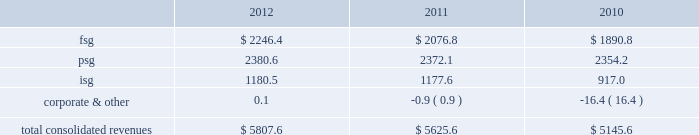Strategy our mission is to achieve sustainable revenue and earnings growth through providing superior solutions to our customers .
Our strategy to achieve this has been and will continue to be built on the following pillars : 2022 expand client relationships 2014 the overall market we serve continues to gravitate beyond single-product purchases to multi-solution partnerships .
As the market dynamics shift , we expect our clients to rely more on our multidimensional service offerings .
Our leveraged solutions and processing expertise can drive meaningful value and cost savings to our clients through more efficient operating processes , improved service quality and speed for our clients' customers .
2022 buy , build or partner to add solutions to cross-sell 2014 we continue to invest in growth through internal product development , as well as through product-focused or market-centric acquisitions that complement and extend our existing capabilities and provide us with additional solutions to cross-sell .
We also partner from time to time with other entities to provide comprehensive offerings to our customers .
By investing in solution innovation and integration , we continue to expand our value proposition to clients .
2022 support our clients through market transformation 2014 the changing market dynamics are transforming the way our clients operate , which is driving incremental demand for our leveraged solutions , consulting expertise , and services around intellectual property .
Our depth of services capabilities enables us to become involved earlier in the planning and design process to assist our clients as they manage through these changes .
2022 continually improve to drive margin expansion 2014 we strive to optimize our performance through investments in infrastructure enhancements and other measures that are designed to drive organic revenue growth and margin expansion .
2022 build global diversification 2014 we continue to deploy resources in emerging global markets where we expect to achieve meaningful scale .
Revenues by segment the table below summarizes the revenues by our reporting segments ( in millions ) : .
Financial solutions group the focus of fsg is to provide the most comprehensive software and services for the core processing , customer channel , treasury services , cash management , wealth management and capital market operations of our financial institution customers in north america .
We service the core and related ancillary processing needs of north american banks , credit unions , automotive financial companies , commercial lenders , and independent community and savings institutions .
Fis offers a broad selection of in-house and outsourced solutions to banking customers that span the range of asset sizes .
Fsg customers are typically committed under multi-year contracts that provide a stable , recurring revenue base and opportunities for cross-selling additional financial and payments offerings .
We employ several business models to provide our solutions to our customers .
We typically deliver the highest value to our customers when we combine our software applications and deliver them in one of several types of outsourcing arrangements , such as an application service provider , facilities management processing or an application management arrangement .
We are also able to deliver individual applications through a software licensing arrangement .
Based upon our expertise gained through the foregoing arrangements , some clients also retain us to manage their it operations without using any of our proprietary software .
Our solutions in this segment include: .
What percent of total consolidate revenue was the psg segment in 2012? 
Computations: (2380.6 / 5807.6)
Answer: 0.40991. Strategy our mission is to achieve sustainable revenue and earnings growth through providing superior solutions to our customers .
Our strategy to achieve this has been and will continue to be built on the following pillars : 2022 expand client relationships 2014 the overall market we serve continues to gravitate beyond single-product purchases to multi-solution partnerships .
As the market dynamics shift , we expect our clients to rely more on our multidimensional service offerings .
Our leveraged solutions and processing expertise can drive meaningful value and cost savings to our clients through more efficient operating processes , improved service quality and speed for our clients' customers .
2022 buy , build or partner to add solutions to cross-sell 2014 we continue to invest in growth through internal product development , as well as through product-focused or market-centric acquisitions that complement and extend our existing capabilities and provide us with additional solutions to cross-sell .
We also partner from time to time with other entities to provide comprehensive offerings to our customers .
By investing in solution innovation and integration , we continue to expand our value proposition to clients .
2022 support our clients through market transformation 2014 the changing market dynamics are transforming the way our clients operate , which is driving incremental demand for our leveraged solutions , consulting expertise , and services around intellectual property .
Our depth of services capabilities enables us to become involved earlier in the planning and design process to assist our clients as they manage through these changes .
2022 continually improve to drive margin expansion 2014 we strive to optimize our performance through investments in infrastructure enhancements and other measures that are designed to drive organic revenue growth and margin expansion .
2022 build global diversification 2014 we continue to deploy resources in emerging global markets where we expect to achieve meaningful scale .
Revenues by segment the table below summarizes the revenues by our reporting segments ( in millions ) : .
Financial solutions group the focus of fsg is to provide the most comprehensive software and services for the core processing , customer channel , treasury services , cash management , wealth management and capital market operations of our financial institution customers in north america .
We service the core and related ancillary processing needs of north american banks , credit unions , automotive financial companies , commercial lenders , and independent community and savings institutions .
Fis offers a broad selection of in-house and outsourced solutions to banking customers that span the range of asset sizes .
Fsg customers are typically committed under multi-year contracts that provide a stable , recurring revenue base and opportunities for cross-selling additional financial and payments offerings .
We employ several business models to provide our solutions to our customers .
We typically deliver the highest value to our customers when we combine our software applications and deliver them in one of several types of outsourcing arrangements , such as an application service provider , facilities management processing or an application management arrangement .
We are also able to deliver individual applications through a software licensing arrangement .
Based upon our expertise gained through the foregoing arrangements , some clients also retain us to manage their it operations without using any of our proprietary software .
Our solutions in this segment include: .
What is the growth rate in the consolidated revenues from 2011 to 2012? 
Computations: ((5807.6 - 5625.6) / 5625.6)
Answer: 0.03235. 